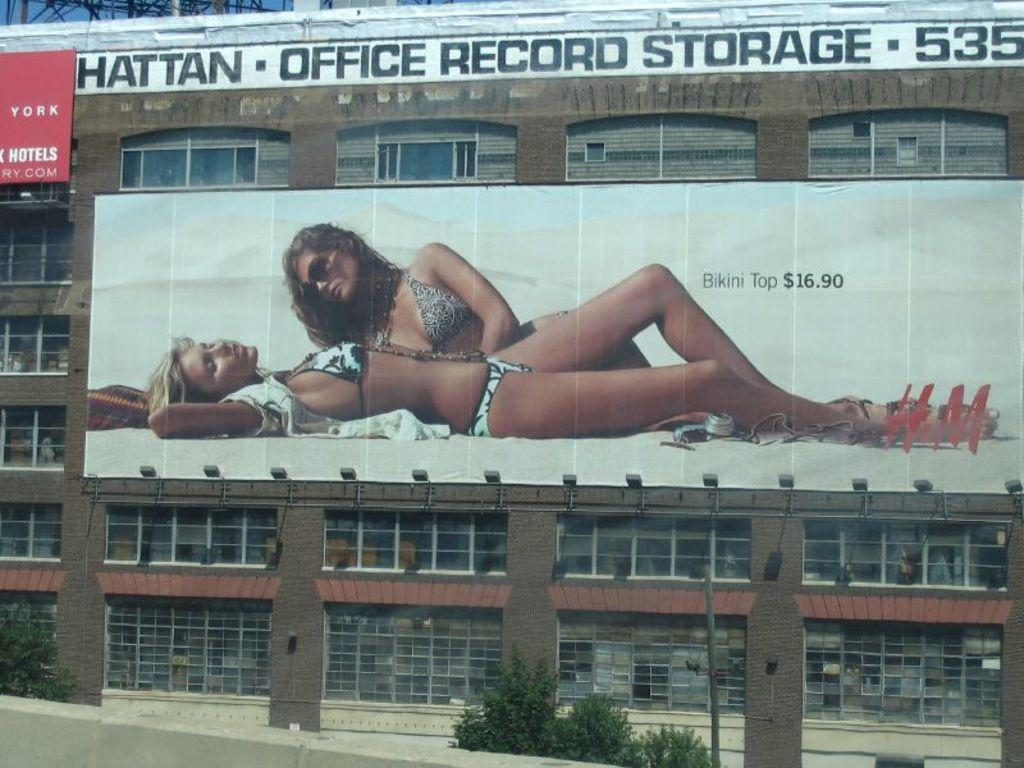<image>
Offer a succinct explanation of the picture presented. A billboard showing two women advertises a bikini top for $16.90. 